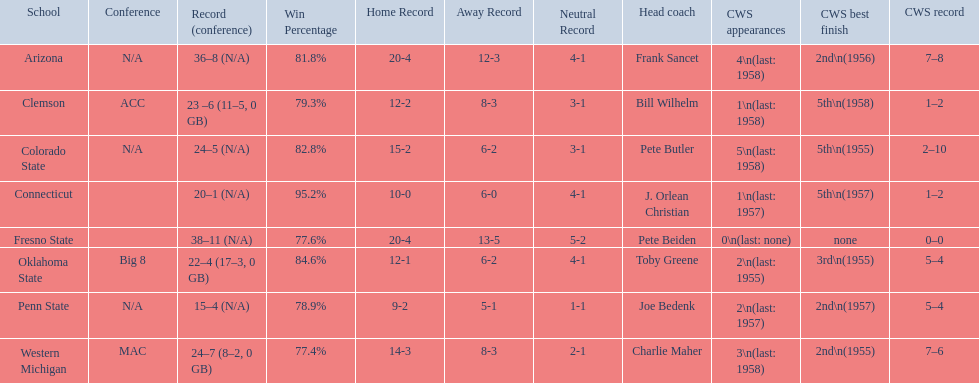Which teams played in the 1959 ncaa university division baseball tournament? Arizona, Clemson, Colorado State, Connecticut, Fresno State, Oklahoma State, Penn State, Western Michigan. Which was the only one to win less than 20 games? Penn State. 